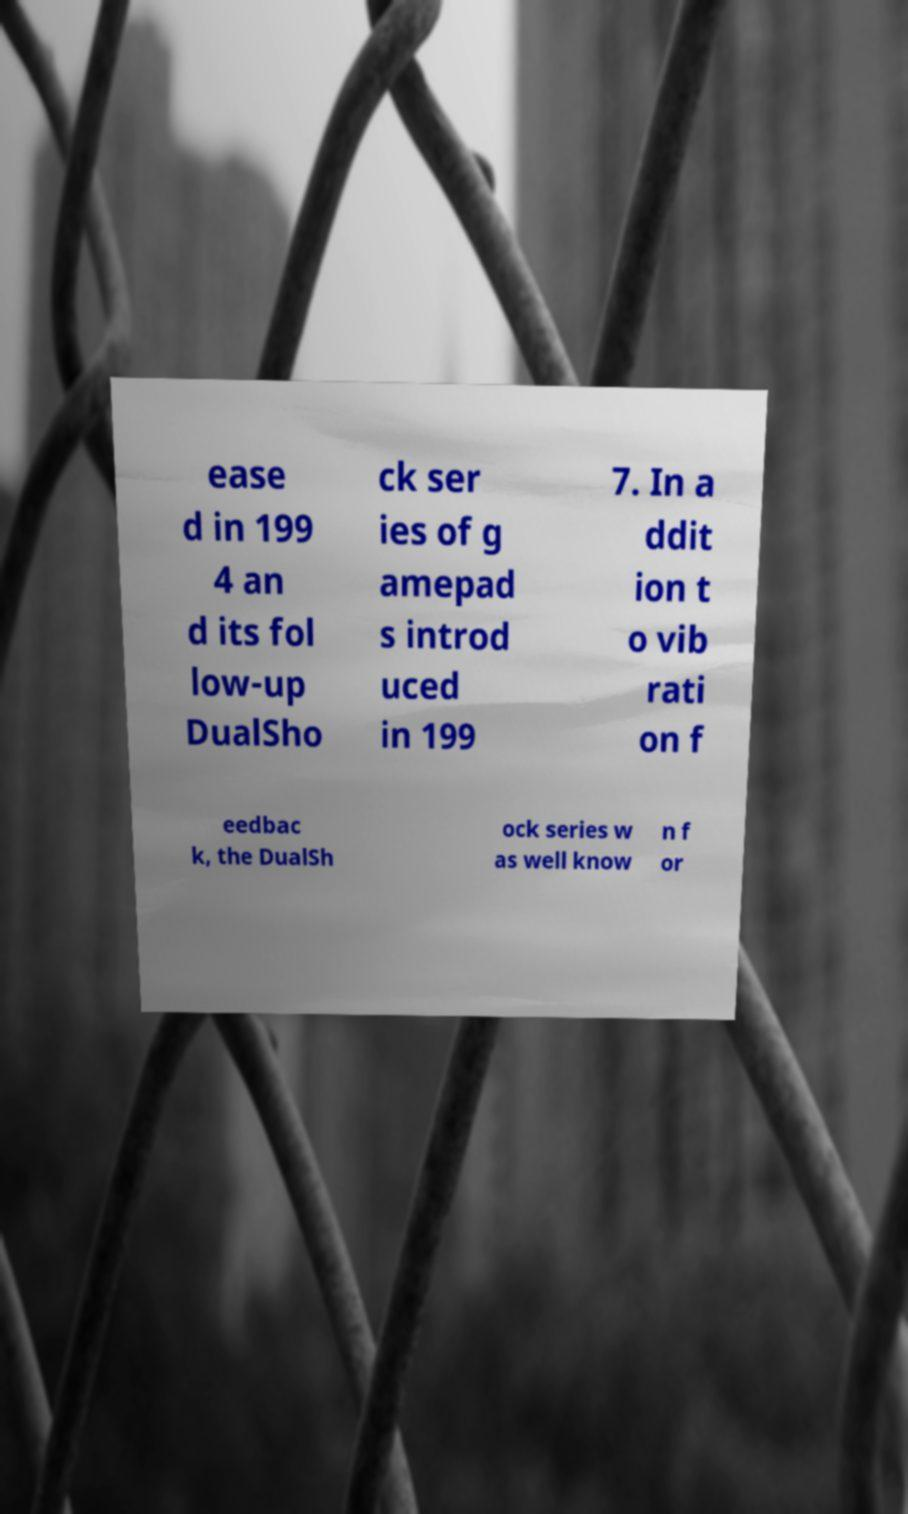Could you extract and type out the text from this image? ease d in 199 4 an d its fol low-up DualSho ck ser ies of g amepad s introd uced in 199 7. In a ddit ion t o vib rati on f eedbac k, the DualSh ock series w as well know n f or 